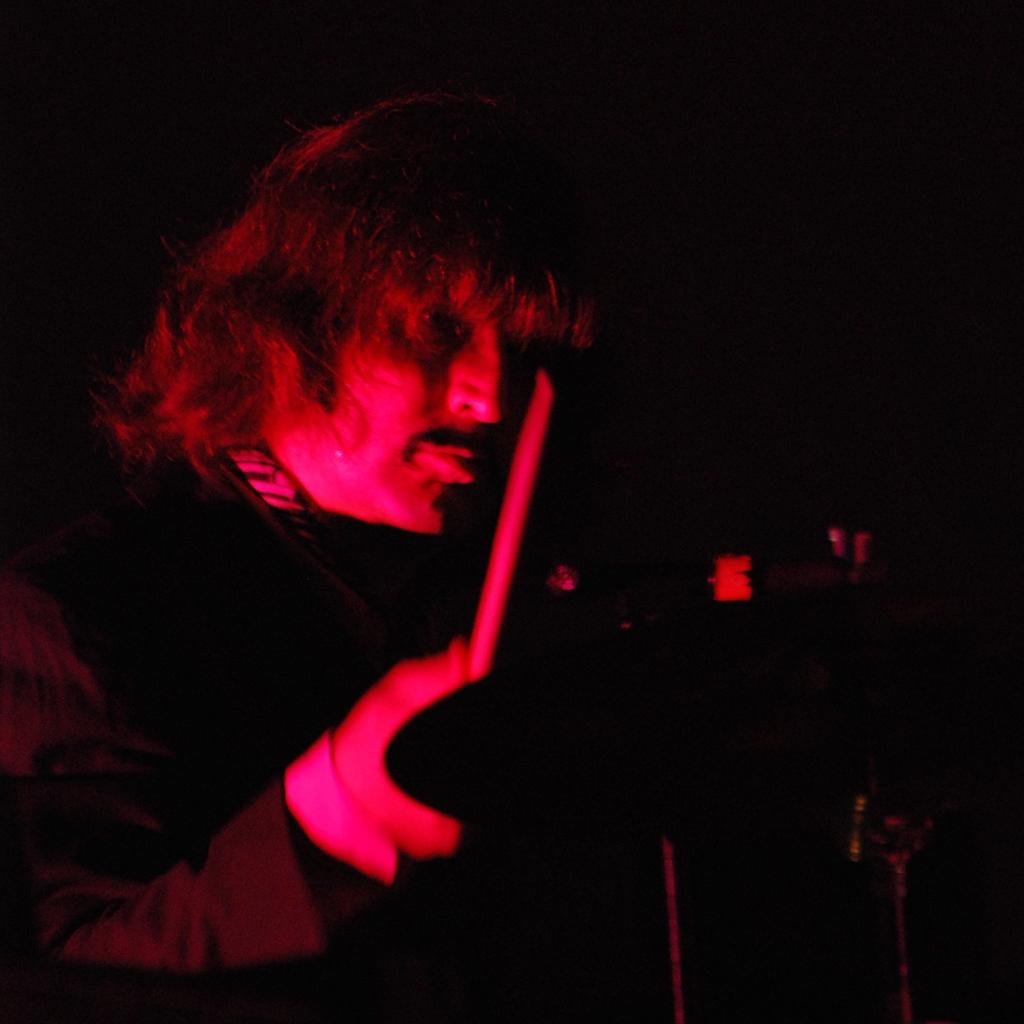What is the main subject of the image? There is a man in the image. What is the man holding in his hand? The man is holding a stick in his hand. Can you describe the object on the right side of the image? Unfortunately, the provided facts do not give any information about the object on the right side of the image. How many beds can be seen in the image? There are no beds present in the image. What type of bait is the man using with the stick in the image? There is no indication in the image that the man is using the stick for fishing or any other activity involving bait. 